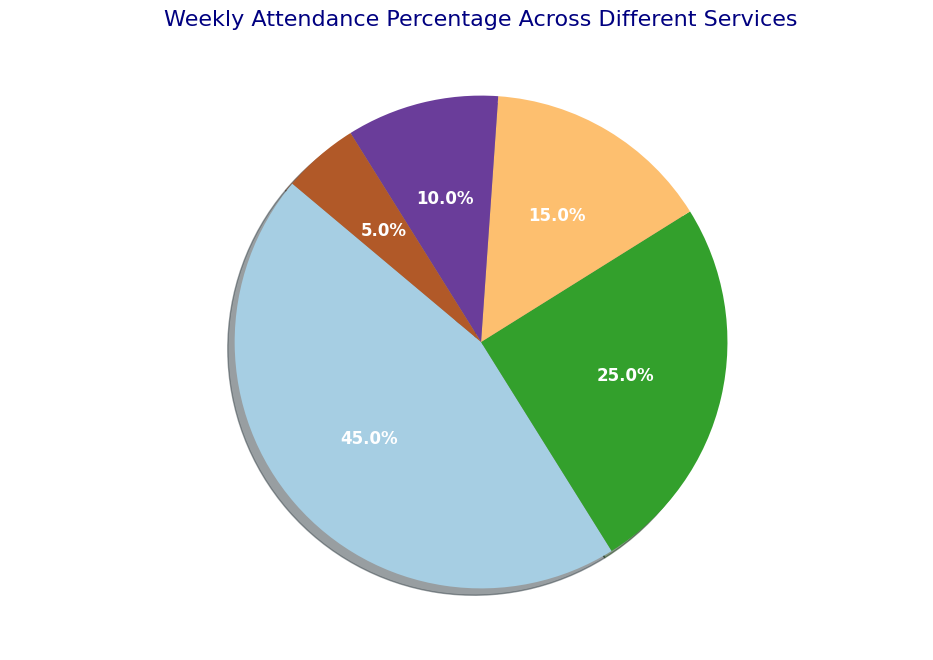What percentage of the total attendance does the Sunday Morning Service account for? The pie chart shows that the Sunday Morning Service has a 45% attendance.
Answer: 45% Which service has the lowest attendance percentage and what is that percentage? The pie chart shows that Youth Fellowship has the lowest attendance percentage, marked at 5%.
Answer: Youth Fellowship, 5% What is the combined attendance percentage of Evening Prayers and Special Liturgies? The chart indicates that Evening Prayers account for 25% and Special Liturgies for 15%. Adding these two gives 25% + 15% = 40%.
Answer: 40% How does the attendance of Bible Study compare to Youth Fellowship? The chart shows that Bible Study has a 10% attendance, while Youth Fellowship has a 5%. Thus, Bible Study has twice the attendance of Youth Fellowship.
Answer: Bible Study has twice as much as Youth Fellowship What is the difference in attendance percentage between the most attended and least attended services? The most attended service is the Sunday Morning Service with 45%, and the least attended is Youth Fellowship with 5%. The difference is 45% - 5% = 40%.
Answer: 40% Name the services attended by at least 10% of the total attendees. The chart indicates that the services attended by at least 10% are Sunday Morning Service (45%), Evening Prayers (25%), Special Liturgies (15%), and Bible Study (10%).
Answer: Sunday Morning Service, Evening Prayers, Special Liturgies, Bible Study By what percentage does the attendance of Evening Prayers exceed that of Bible Study? The attendance for Evening Prayers is 25%, and for Bible Study it's 10%. The difference is 25% - 10% = 15%, so the Evening Prayers exceed Bible Study by 15%.
Answer: 15% If combined attendance for Special Liturgies and Youth Fellowship is considered, how does it compare with the attendance of Evening Prayers? Special Liturgies have 15% and Youth Fellowship has 5%, together summing up to 15% + 5% = 20%, while Evening Prayers alone have 25%. Thus, combined attendance of Special Liturgies and Youth Fellowship (20%) is less than Evening Prayers (25%).
Answer: 20% < 25% Which service is represented by the largest segment in the pie chart? The largest segment in the pie chart corresponds to the Sunday Morning Service with 45%.
Answer: Sunday Morning Service Considering services with at least 15% attendance, what is their contribution to the total weekly attendance? The services with at least 15% attendance are Sunday Morning Service (45%), Evening Prayers (25%), and Special Liturgies (15%). Adding these percentages gives 45% + 25% + 15% = 85%.
Answer: 85% 